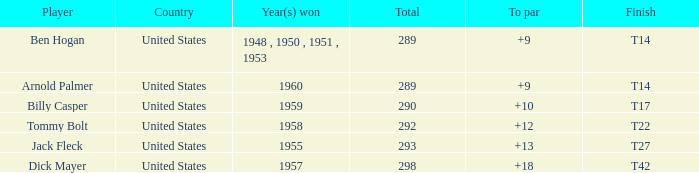What is the sum of total when to par equals 12? 1.0. Would you be able to parse every entry in this table? {'header': ['Player', 'Country', 'Year(s) won', 'Total', 'To par', 'Finish'], 'rows': [['Ben Hogan', 'United States', '1948 , 1950 , 1951 , 1953', '289', '+9', 'T14'], ['Arnold Palmer', 'United States', '1960', '289', '+9', 'T14'], ['Billy Casper', 'United States', '1959', '290', '+10', 'T17'], ['Tommy Bolt', 'United States', '1958', '292', '+12', 'T22'], ['Jack Fleck', 'United States', '1955', '293', '+13', 'T27'], ['Dick Mayer', 'United States', '1957', '298', '+18', 'T42']]} 